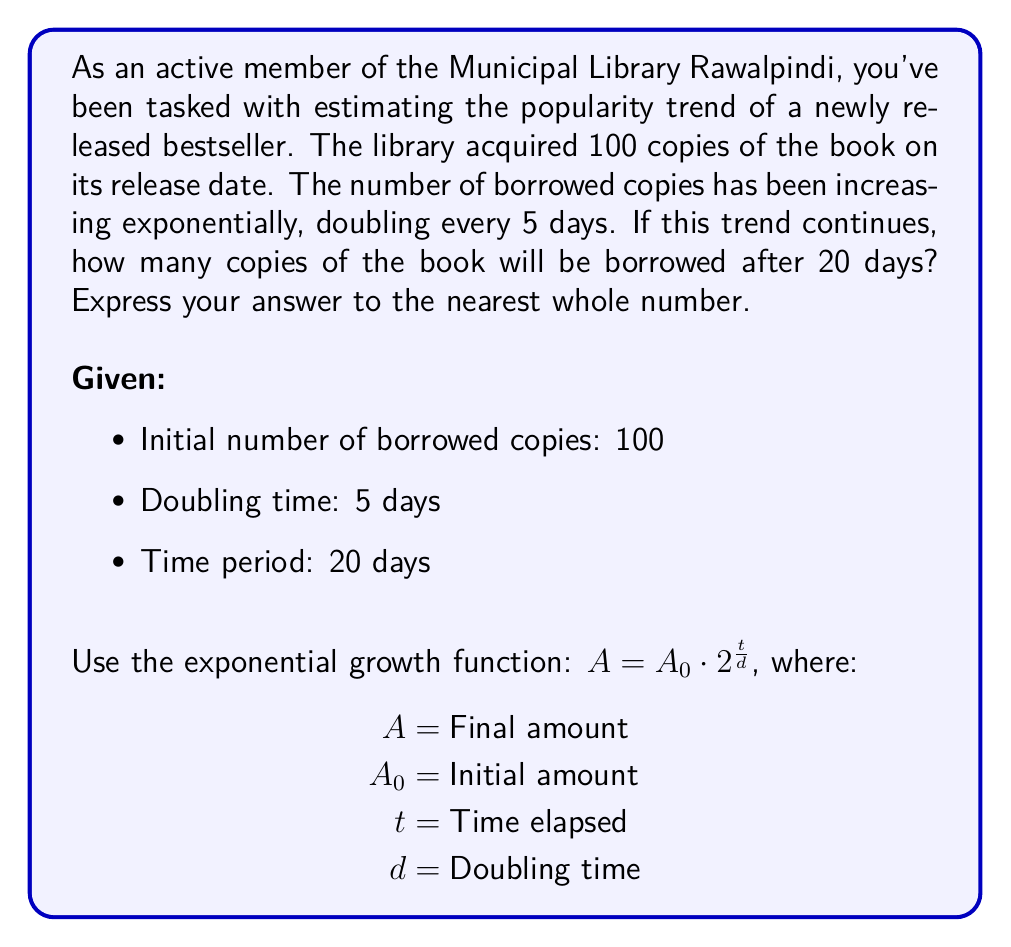Teach me how to tackle this problem. To solve this problem, we'll use the exponential growth function:

$$A = A_0 \cdot 2^{\frac{t}{d}}$$

Where:
$A$ = Number of borrowed copies after 20 days
$A_0 = 100$ (initial number of borrowed copies)
$t = 20$ days (time elapsed)
$d = 5$ days (doubling time)

Let's substitute these values into the equation:

$$A = 100 \cdot 2^{\frac{20}{5}}$$

Now, we can simplify the exponent:

$$A = 100 \cdot 2^4$$

Calculate $2^4$:

$$A = 100 \cdot 16$$

Multiply:

$$A = 1600$$

Therefore, after 20 days, 1600 copies of the book will be borrowed if the exponential trend continues.
Answer: 1600 copies 